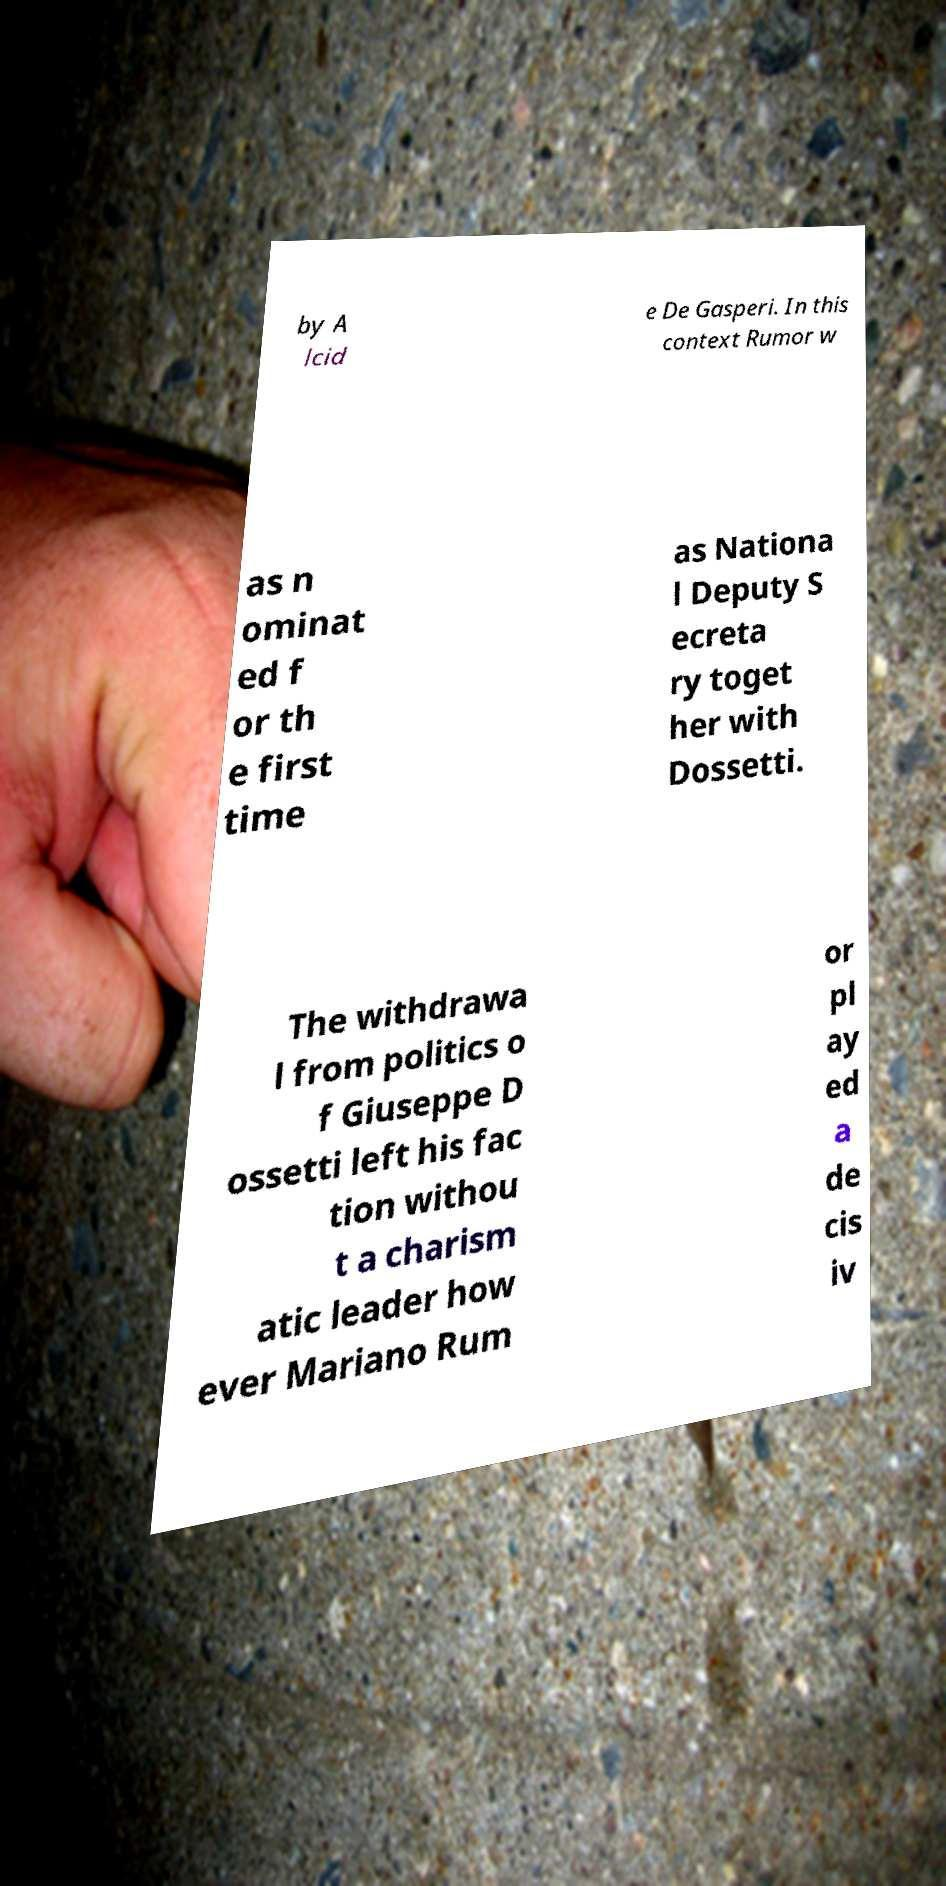Can you accurately transcribe the text from the provided image for me? by A lcid e De Gasperi. In this context Rumor w as n ominat ed f or th e first time as Nationa l Deputy S ecreta ry toget her with Dossetti. The withdrawa l from politics o f Giuseppe D ossetti left his fac tion withou t a charism atic leader how ever Mariano Rum or pl ay ed a de cis iv 